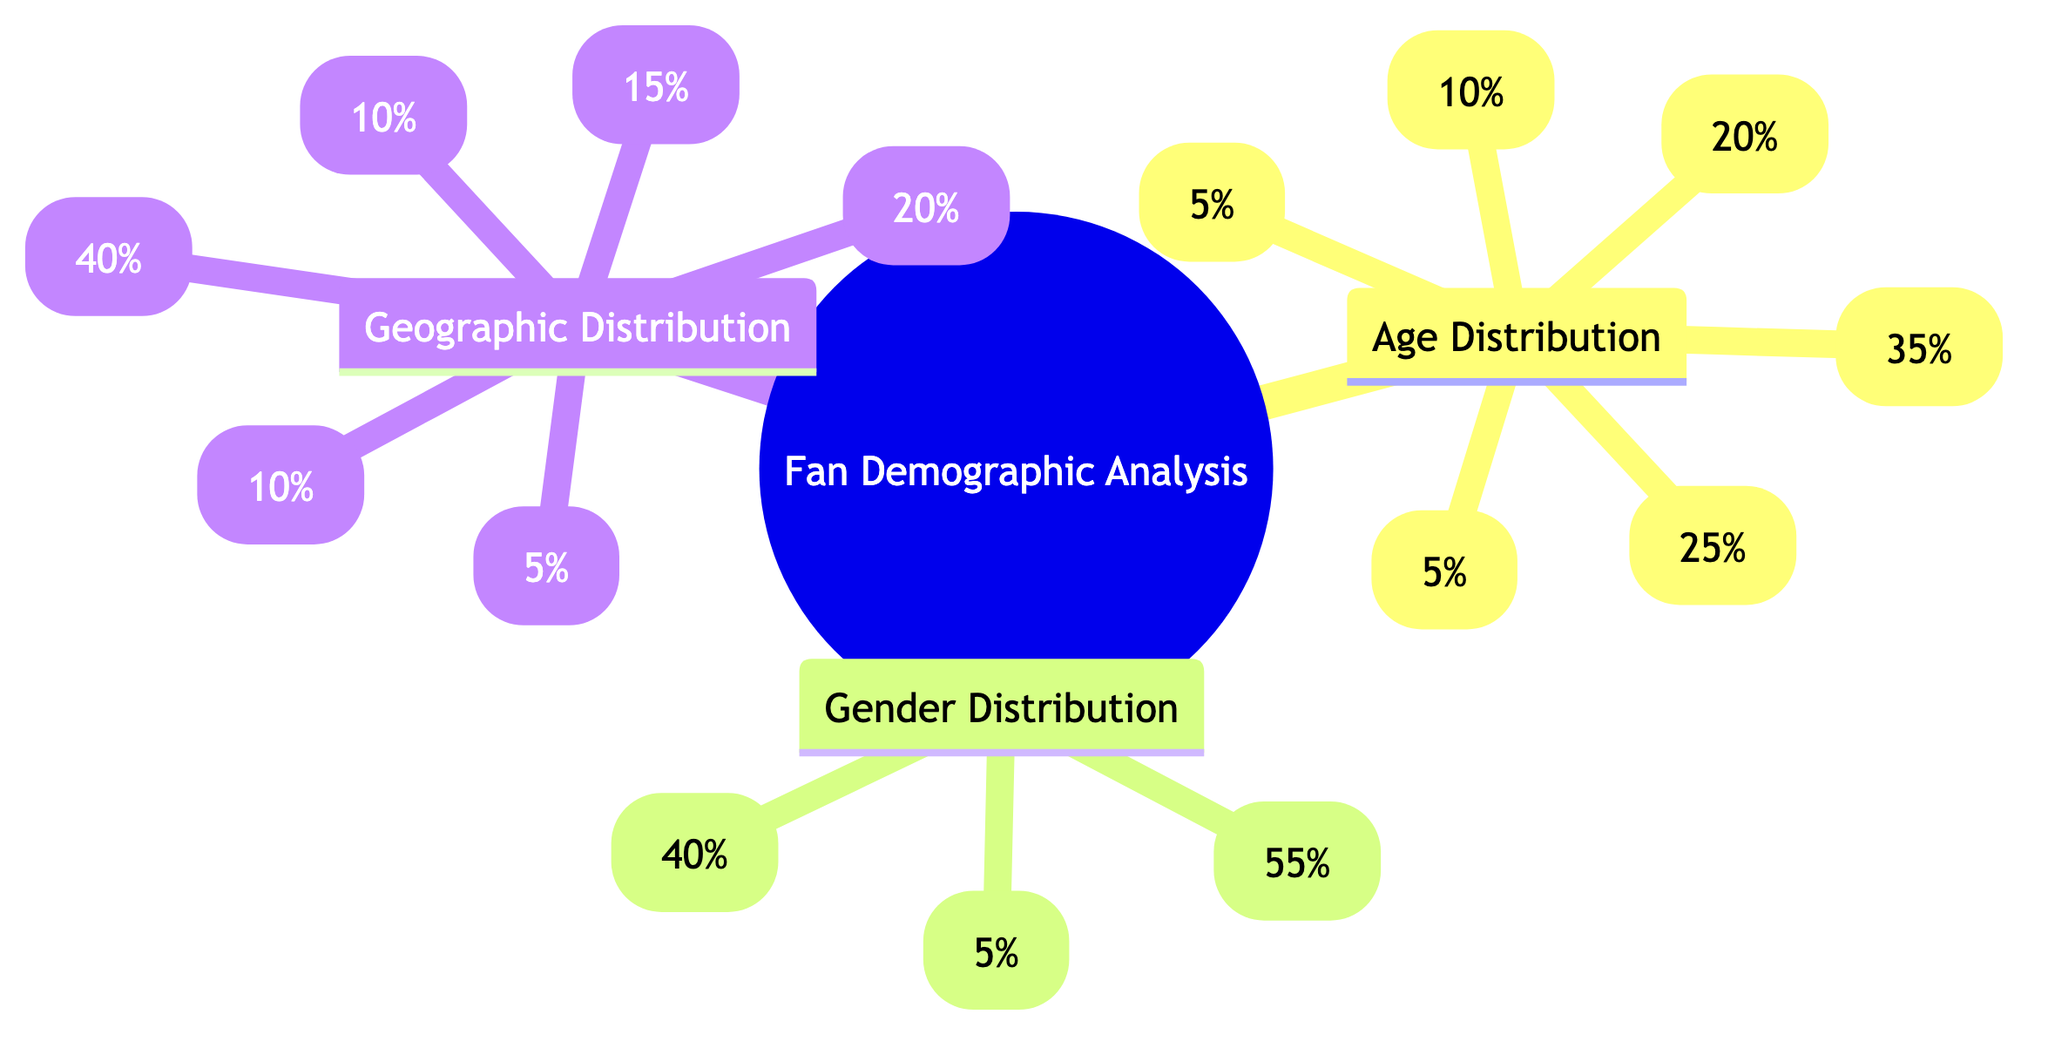what percentage of fans are aged 18-24? The Age Distribution section specifically lists the percentage of fans aged 18-24 as 25%.
Answer: 25% what is the total percentage of fans aged 55 and older? To find the total percentage of fans aged 55 and older, we sum the percentages for the age groups 55+ (5%) and 45-54 (10%), resulting in 5% + 10% = 15%.
Answer: 15% how many fans identify as Non-Binary? The Gender Distribution section indicates that 5% of fans identify as Non-Binary.
Answer: 5% which city has the largest geographic representation? The Geographic Distribution section shows that Nashville, TN has the highest percentage of representation at 40%.
Answer: Nashville, TN what is the ratio of male to female fans? From the Gender Distribution, there are 40% Male fans and 55% Female fans. To find the ratio, we express these percentages as a fraction: 40:55, which simplifies to 8:11.
Answer: 8:11 what percentage of fans come from cities outside the top five listed? The Geographic Distribution lists specific cities with their percentages, totaling 80% (40% + 15% + 10% + 10% + 5%). This means 20% of fans fall under the 'Other' category, indicating they come from cities outside the top five.
Answer: 20% how does the age group 25-34 compare to the 35-44 age group in terms of percentage? The Age Distribution indicates that 35% of fans are aged 25-34 while 20% are aged 35-44. This shows that the 25-34 age group has a larger representation by a difference of 15%.
Answer: 15% what is the total number of age groups represented in the diagram? By counting each distinct age range listed in the Age Distribution, we find there are six age groups: <18, 18-24, 25-34, 35-44, 45-54, and 55+.
Answer: 6 how does the percentage of female fans compare to the total percentage of fans aged 45 and older? The Gender Distribution indicates Female fans at 55%, while the age groups 45-54 and 55+ together account for 15% (10% + 5%). Thus, Female fans exceed the older age groups by 40%.
Answer: 40% 